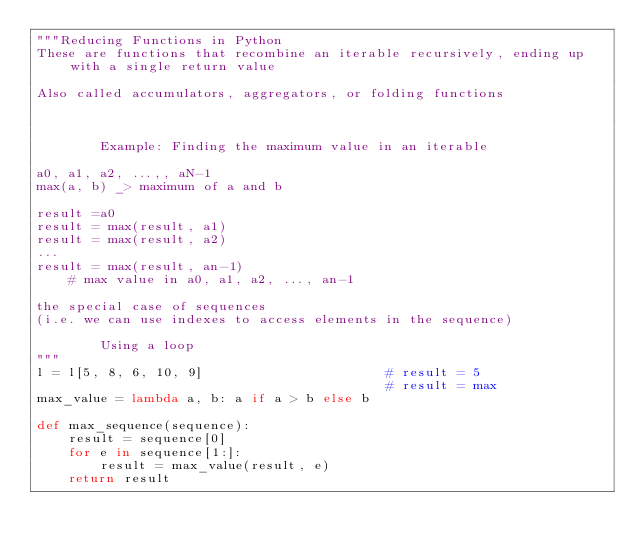<code> <loc_0><loc_0><loc_500><loc_500><_Python_>"""Reducing Functions in Python
These are functions that recombine an iterable recursively, ending up with a single return value

Also called accumulators, aggregators, or folding functions



        Example: Finding the maximum value in an iterable

a0, a1, a2, ...,, aN-1
max(a, b) _> maximum of a and b

result =a0
result = max(result, a1)
result = max(result, a2)
...
result = max(result, an-1)
    # max value in a0, a1, a2, ..., an-1

the special case of sequences
(i.e. we can use indexes to access elements in the sequence)

        Using a loop
"""
l = l[5, 8, 6, 10, 9]                       # result = 5
                                            # result = max
max_value = lambda a, b: a if a > b else b

def max_sequence(sequence):
    result = sequence[0]
    for e in sequence[1:]:
        result = max_value(result, e)
    return result
</code> 